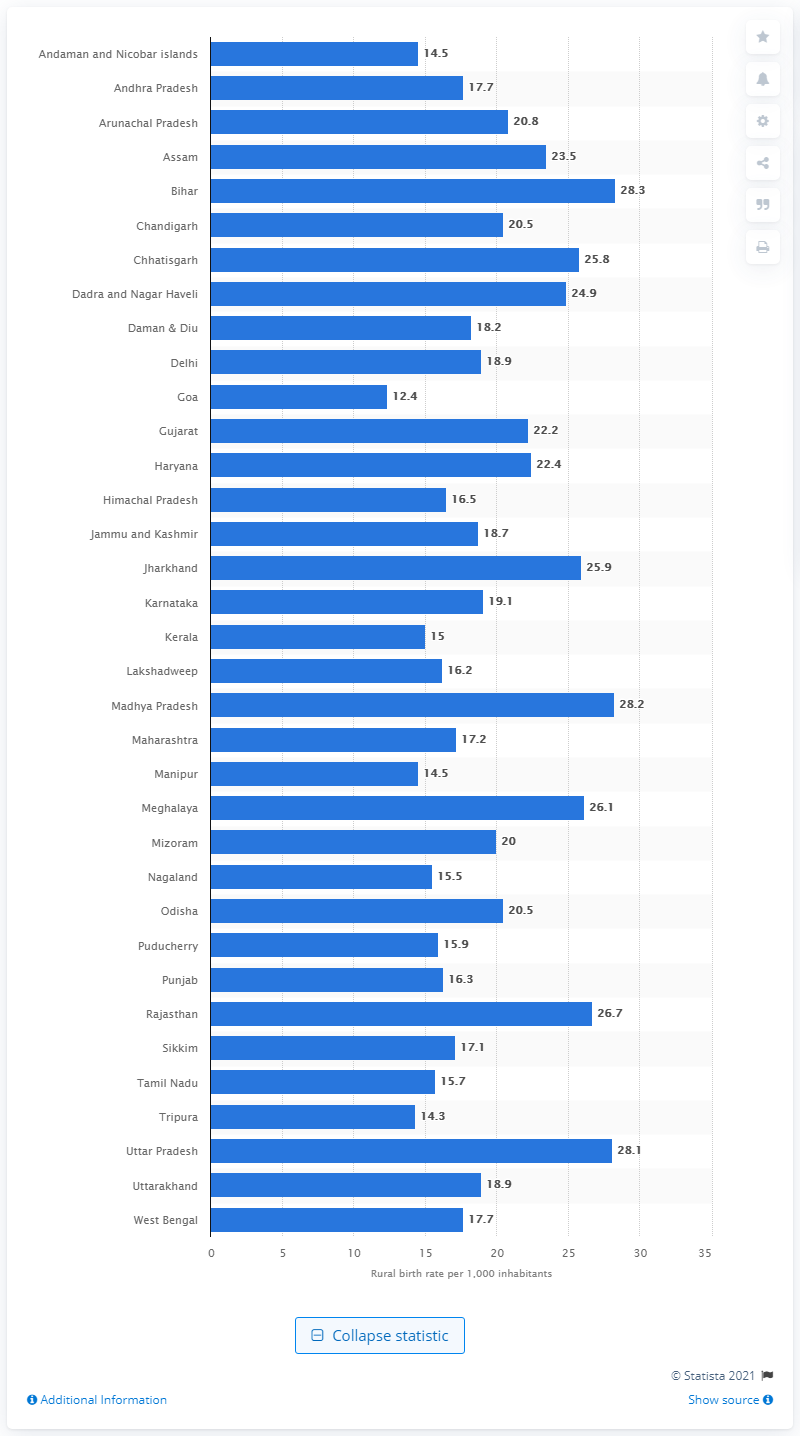Identify some key points in this picture. Madhya Pradesh had the lowest birth rate in 2013 among all the states in India. Goa had the lowest birth rate in 2013 among all the states in India. In 2013, Madhya Pradesh had the lowest birth rate among all the states in India. 